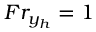Convert formula to latex. <formula><loc_0><loc_0><loc_500><loc_500>F r _ { y _ { h } } = 1</formula> 